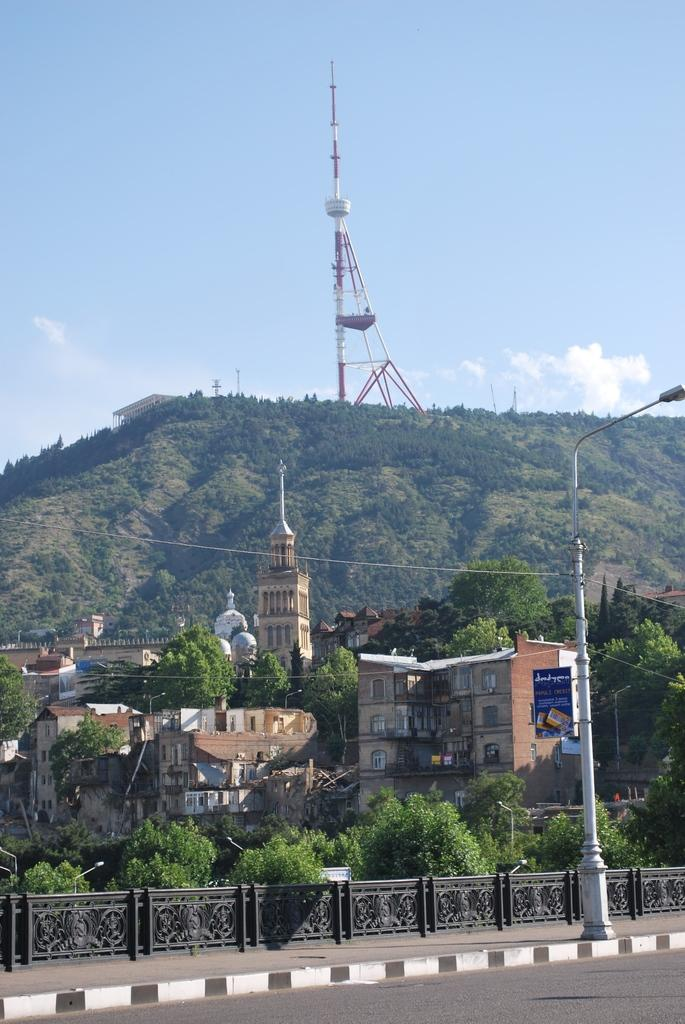What is the main feature of the image? There is a road in the image. What can be seen on the footpath in the image? There is a light pole on the footpath in the image. What is present in the background of the image? In the background of the image, there are trees, houses, a mountain, a tower, and the sky. Can you describe the railing in the image? There is a railing in the background of the image. How many apples are hanging from the trees in the image? There are no apples visible in the image; only trees are present in the background. What type of wave can be seen crashing on the shore in the image? There is no shore or wave present in the image; it features a road, a light pole, a railing, trees, houses, a mountain, a tower, and the sky. 